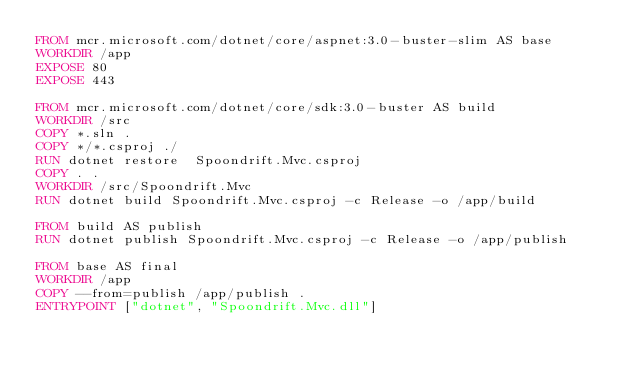<code> <loc_0><loc_0><loc_500><loc_500><_Dockerfile_>FROM mcr.microsoft.com/dotnet/core/aspnet:3.0-buster-slim AS base
WORKDIR /app
EXPOSE 80
EXPOSE 443

FROM mcr.microsoft.com/dotnet/core/sdk:3.0-buster AS build
WORKDIR /src
COPY *.sln .
COPY */*.csproj ./
RUN dotnet restore  Spoondrift.Mvc.csproj
COPY . .
WORKDIR /src/Spoondrift.Mvc 
RUN dotnet build Spoondrift.Mvc.csproj -c Release -o /app/build

FROM build AS publish
RUN dotnet publish Spoondrift.Mvc.csproj -c Release -o /app/publish

FROM base AS final
WORKDIR /app
COPY --from=publish /app/publish .
ENTRYPOINT ["dotnet", "Spoondrift.Mvc.dll"]</code> 